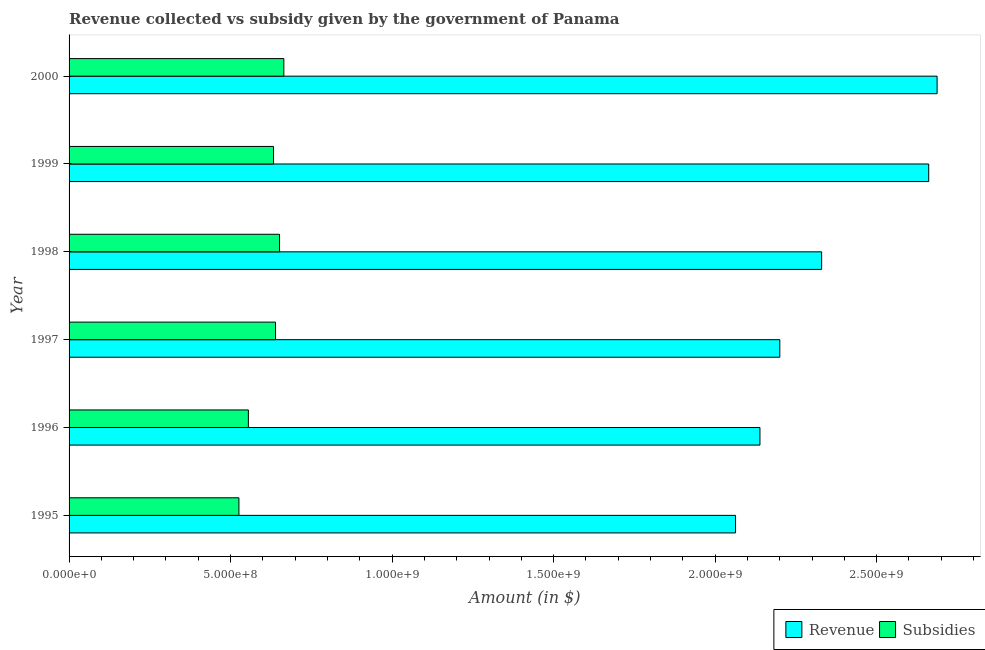How many bars are there on the 1st tick from the top?
Keep it short and to the point. 2. What is the amount of revenue collected in 1998?
Your answer should be very brief. 2.33e+09. Across all years, what is the maximum amount of subsidies given?
Your answer should be compact. 6.65e+08. Across all years, what is the minimum amount of revenue collected?
Provide a short and direct response. 2.06e+09. In which year was the amount of revenue collected maximum?
Give a very brief answer. 2000. What is the total amount of subsidies given in the graph?
Keep it short and to the point. 3.67e+09. What is the difference between the amount of subsidies given in 1998 and that in 1999?
Provide a succinct answer. 1.87e+07. What is the difference between the amount of revenue collected in 2000 and the amount of subsidies given in 1999?
Provide a succinct answer. 2.05e+09. What is the average amount of revenue collected per year?
Keep it short and to the point. 2.35e+09. In the year 1998, what is the difference between the amount of subsidies given and amount of revenue collected?
Offer a terse response. -1.68e+09. What is the ratio of the amount of revenue collected in 1998 to that in 2000?
Offer a terse response. 0.87. Is the amount of subsidies given in 1995 less than that in 1996?
Make the answer very short. Yes. Is the difference between the amount of revenue collected in 1996 and 1999 greater than the difference between the amount of subsidies given in 1996 and 1999?
Provide a succinct answer. No. What is the difference between the highest and the second highest amount of subsidies given?
Your answer should be very brief. 1.33e+07. What is the difference between the highest and the lowest amount of revenue collected?
Offer a terse response. 6.24e+08. Is the sum of the amount of revenue collected in 1997 and 1998 greater than the maximum amount of subsidies given across all years?
Ensure brevity in your answer.  Yes. What does the 1st bar from the top in 1999 represents?
Ensure brevity in your answer.  Subsidies. What does the 2nd bar from the bottom in 1997 represents?
Provide a succinct answer. Subsidies. Are all the bars in the graph horizontal?
Provide a succinct answer. Yes. Where does the legend appear in the graph?
Make the answer very short. Bottom right. What is the title of the graph?
Ensure brevity in your answer.  Revenue collected vs subsidy given by the government of Panama. Does "Under-5(female)" appear as one of the legend labels in the graph?
Provide a short and direct response. No. What is the label or title of the X-axis?
Offer a very short reply. Amount (in $). What is the label or title of the Y-axis?
Ensure brevity in your answer.  Year. What is the Amount (in $) in Revenue in 1995?
Your answer should be very brief. 2.06e+09. What is the Amount (in $) of Subsidies in 1995?
Your answer should be compact. 5.26e+08. What is the Amount (in $) in Revenue in 1996?
Ensure brevity in your answer.  2.14e+09. What is the Amount (in $) in Subsidies in 1996?
Keep it short and to the point. 5.55e+08. What is the Amount (in $) in Revenue in 1997?
Provide a short and direct response. 2.20e+09. What is the Amount (in $) in Subsidies in 1997?
Give a very brief answer. 6.39e+08. What is the Amount (in $) of Revenue in 1998?
Provide a succinct answer. 2.33e+09. What is the Amount (in $) in Subsidies in 1998?
Provide a succinct answer. 6.52e+08. What is the Amount (in $) in Revenue in 1999?
Ensure brevity in your answer.  2.66e+09. What is the Amount (in $) of Subsidies in 1999?
Keep it short and to the point. 6.33e+08. What is the Amount (in $) of Revenue in 2000?
Make the answer very short. 2.69e+09. What is the Amount (in $) in Subsidies in 2000?
Provide a short and direct response. 6.65e+08. Across all years, what is the maximum Amount (in $) of Revenue?
Your answer should be compact. 2.69e+09. Across all years, what is the maximum Amount (in $) of Subsidies?
Make the answer very short. 6.65e+08. Across all years, what is the minimum Amount (in $) of Revenue?
Your answer should be compact. 2.06e+09. Across all years, what is the minimum Amount (in $) of Subsidies?
Provide a succinct answer. 5.26e+08. What is the total Amount (in $) in Revenue in the graph?
Offer a very short reply. 1.41e+1. What is the total Amount (in $) in Subsidies in the graph?
Make the answer very short. 3.67e+09. What is the difference between the Amount (in $) of Revenue in 1995 and that in 1996?
Make the answer very short. -7.56e+07. What is the difference between the Amount (in $) of Subsidies in 1995 and that in 1996?
Keep it short and to the point. -2.93e+07. What is the difference between the Amount (in $) in Revenue in 1995 and that in 1997?
Make the answer very short. -1.37e+08. What is the difference between the Amount (in $) of Subsidies in 1995 and that in 1997?
Your response must be concise. -1.13e+08. What is the difference between the Amount (in $) in Revenue in 1995 and that in 1998?
Ensure brevity in your answer.  -2.67e+08. What is the difference between the Amount (in $) in Subsidies in 1995 and that in 1998?
Provide a short and direct response. -1.26e+08. What is the difference between the Amount (in $) of Revenue in 1995 and that in 1999?
Offer a very short reply. -5.98e+08. What is the difference between the Amount (in $) of Subsidies in 1995 and that in 1999?
Provide a succinct answer. -1.07e+08. What is the difference between the Amount (in $) of Revenue in 1995 and that in 2000?
Provide a succinct answer. -6.24e+08. What is the difference between the Amount (in $) in Subsidies in 1995 and that in 2000?
Provide a short and direct response. -1.39e+08. What is the difference between the Amount (in $) in Revenue in 1996 and that in 1997?
Keep it short and to the point. -6.15e+07. What is the difference between the Amount (in $) of Subsidies in 1996 and that in 1997?
Ensure brevity in your answer.  -8.40e+07. What is the difference between the Amount (in $) in Revenue in 1996 and that in 1998?
Your answer should be compact. -1.91e+08. What is the difference between the Amount (in $) in Subsidies in 1996 and that in 1998?
Make the answer very short. -9.65e+07. What is the difference between the Amount (in $) in Revenue in 1996 and that in 1999?
Ensure brevity in your answer.  -5.22e+08. What is the difference between the Amount (in $) of Subsidies in 1996 and that in 1999?
Keep it short and to the point. -7.78e+07. What is the difference between the Amount (in $) in Revenue in 1996 and that in 2000?
Your answer should be compact. -5.48e+08. What is the difference between the Amount (in $) in Subsidies in 1996 and that in 2000?
Provide a succinct answer. -1.10e+08. What is the difference between the Amount (in $) of Revenue in 1997 and that in 1998?
Keep it short and to the point. -1.30e+08. What is the difference between the Amount (in $) in Subsidies in 1997 and that in 1998?
Provide a short and direct response. -1.25e+07. What is the difference between the Amount (in $) in Revenue in 1997 and that in 1999?
Give a very brief answer. -4.61e+08. What is the difference between the Amount (in $) of Subsidies in 1997 and that in 1999?
Keep it short and to the point. 6.20e+06. What is the difference between the Amount (in $) in Revenue in 1997 and that in 2000?
Keep it short and to the point. -4.87e+08. What is the difference between the Amount (in $) in Subsidies in 1997 and that in 2000?
Give a very brief answer. -2.58e+07. What is the difference between the Amount (in $) in Revenue in 1998 and that in 1999?
Your answer should be compact. -3.32e+08. What is the difference between the Amount (in $) of Subsidies in 1998 and that in 1999?
Your answer should be compact. 1.87e+07. What is the difference between the Amount (in $) in Revenue in 1998 and that in 2000?
Ensure brevity in your answer.  -3.57e+08. What is the difference between the Amount (in $) in Subsidies in 1998 and that in 2000?
Offer a very short reply. -1.33e+07. What is the difference between the Amount (in $) of Revenue in 1999 and that in 2000?
Your answer should be very brief. -2.59e+07. What is the difference between the Amount (in $) in Subsidies in 1999 and that in 2000?
Your answer should be compact. -3.20e+07. What is the difference between the Amount (in $) of Revenue in 1995 and the Amount (in $) of Subsidies in 1996?
Your answer should be compact. 1.51e+09. What is the difference between the Amount (in $) in Revenue in 1995 and the Amount (in $) in Subsidies in 1997?
Keep it short and to the point. 1.42e+09. What is the difference between the Amount (in $) of Revenue in 1995 and the Amount (in $) of Subsidies in 1998?
Give a very brief answer. 1.41e+09. What is the difference between the Amount (in $) in Revenue in 1995 and the Amount (in $) in Subsidies in 1999?
Ensure brevity in your answer.  1.43e+09. What is the difference between the Amount (in $) in Revenue in 1995 and the Amount (in $) in Subsidies in 2000?
Your answer should be very brief. 1.40e+09. What is the difference between the Amount (in $) of Revenue in 1996 and the Amount (in $) of Subsidies in 1997?
Your response must be concise. 1.50e+09. What is the difference between the Amount (in $) in Revenue in 1996 and the Amount (in $) in Subsidies in 1998?
Give a very brief answer. 1.49e+09. What is the difference between the Amount (in $) in Revenue in 1996 and the Amount (in $) in Subsidies in 1999?
Your answer should be compact. 1.51e+09. What is the difference between the Amount (in $) in Revenue in 1996 and the Amount (in $) in Subsidies in 2000?
Your response must be concise. 1.47e+09. What is the difference between the Amount (in $) in Revenue in 1997 and the Amount (in $) in Subsidies in 1998?
Make the answer very short. 1.55e+09. What is the difference between the Amount (in $) of Revenue in 1997 and the Amount (in $) of Subsidies in 1999?
Offer a terse response. 1.57e+09. What is the difference between the Amount (in $) in Revenue in 1997 and the Amount (in $) in Subsidies in 2000?
Offer a very short reply. 1.54e+09. What is the difference between the Amount (in $) in Revenue in 1998 and the Amount (in $) in Subsidies in 1999?
Provide a succinct answer. 1.70e+09. What is the difference between the Amount (in $) of Revenue in 1998 and the Amount (in $) of Subsidies in 2000?
Provide a succinct answer. 1.66e+09. What is the difference between the Amount (in $) in Revenue in 1999 and the Amount (in $) in Subsidies in 2000?
Offer a terse response. 2.00e+09. What is the average Amount (in $) of Revenue per year?
Offer a very short reply. 2.35e+09. What is the average Amount (in $) of Subsidies per year?
Keep it short and to the point. 6.12e+08. In the year 1995, what is the difference between the Amount (in $) in Revenue and Amount (in $) in Subsidies?
Your response must be concise. 1.54e+09. In the year 1996, what is the difference between the Amount (in $) of Revenue and Amount (in $) of Subsidies?
Make the answer very short. 1.58e+09. In the year 1997, what is the difference between the Amount (in $) of Revenue and Amount (in $) of Subsidies?
Offer a terse response. 1.56e+09. In the year 1998, what is the difference between the Amount (in $) in Revenue and Amount (in $) in Subsidies?
Keep it short and to the point. 1.68e+09. In the year 1999, what is the difference between the Amount (in $) of Revenue and Amount (in $) of Subsidies?
Your answer should be very brief. 2.03e+09. In the year 2000, what is the difference between the Amount (in $) of Revenue and Amount (in $) of Subsidies?
Provide a succinct answer. 2.02e+09. What is the ratio of the Amount (in $) of Revenue in 1995 to that in 1996?
Provide a short and direct response. 0.96. What is the ratio of the Amount (in $) of Subsidies in 1995 to that in 1996?
Provide a short and direct response. 0.95. What is the ratio of the Amount (in $) in Revenue in 1995 to that in 1997?
Keep it short and to the point. 0.94. What is the ratio of the Amount (in $) in Subsidies in 1995 to that in 1997?
Give a very brief answer. 0.82. What is the ratio of the Amount (in $) in Revenue in 1995 to that in 1998?
Offer a very short reply. 0.89. What is the ratio of the Amount (in $) in Subsidies in 1995 to that in 1998?
Provide a succinct answer. 0.81. What is the ratio of the Amount (in $) in Revenue in 1995 to that in 1999?
Make the answer very short. 0.78. What is the ratio of the Amount (in $) in Subsidies in 1995 to that in 1999?
Your answer should be compact. 0.83. What is the ratio of the Amount (in $) of Revenue in 1995 to that in 2000?
Offer a terse response. 0.77. What is the ratio of the Amount (in $) in Subsidies in 1995 to that in 2000?
Provide a short and direct response. 0.79. What is the ratio of the Amount (in $) in Revenue in 1996 to that in 1997?
Your answer should be compact. 0.97. What is the ratio of the Amount (in $) in Subsidies in 1996 to that in 1997?
Provide a succinct answer. 0.87. What is the ratio of the Amount (in $) of Revenue in 1996 to that in 1998?
Your response must be concise. 0.92. What is the ratio of the Amount (in $) in Subsidies in 1996 to that in 1998?
Offer a terse response. 0.85. What is the ratio of the Amount (in $) of Revenue in 1996 to that in 1999?
Offer a very short reply. 0.8. What is the ratio of the Amount (in $) in Subsidies in 1996 to that in 1999?
Provide a short and direct response. 0.88. What is the ratio of the Amount (in $) in Revenue in 1996 to that in 2000?
Your answer should be very brief. 0.8. What is the ratio of the Amount (in $) in Subsidies in 1996 to that in 2000?
Give a very brief answer. 0.83. What is the ratio of the Amount (in $) of Revenue in 1997 to that in 1998?
Your answer should be very brief. 0.94. What is the ratio of the Amount (in $) of Subsidies in 1997 to that in 1998?
Provide a succinct answer. 0.98. What is the ratio of the Amount (in $) in Revenue in 1997 to that in 1999?
Provide a short and direct response. 0.83. What is the ratio of the Amount (in $) in Subsidies in 1997 to that in 1999?
Give a very brief answer. 1.01. What is the ratio of the Amount (in $) of Revenue in 1997 to that in 2000?
Offer a terse response. 0.82. What is the ratio of the Amount (in $) in Subsidies in 1997 to that in 2000?
Keep it short and to the point. 0.96. What is the ratio of the Amount (in $) in Revenue in 1998 to that in 1999?
Your response must be concise. 0.88. What is the ratio of the Amount (in $) in Subsidies in 1998 to that in 1999?
Offer a very short reply. 1.03. What is the ratio of the Amount (in $) of Revenue in 1998 to that in 2000?
Give a very brief answer. 0.87. What is the ratio of the Amount (in $) in Subsidies in 1998 to that in 2000?
Give a very brief answer. 0.98. What is the ratio of the Amount (in $) of Subsidies in 1999 to that in 2000?
Offer a very short reply. 0.95. What is the difference between the highest and the second highest Amount (in $) of Revenue?
Offer a terse response. 2.59e+07. What is the difference between the highest and the second highest Amount (in $) of Subsidies?
Ensure brevity in your answer.  1.33e+07. What is the difference between the highest and the lowest Amount (in $) in Revenue?
Provide a succinct answer. 6.24e+08. What is the difference between the highest and the lowest Amount (in $) in Subsidies?
Keep it short and to the point. 1.39e+08. 